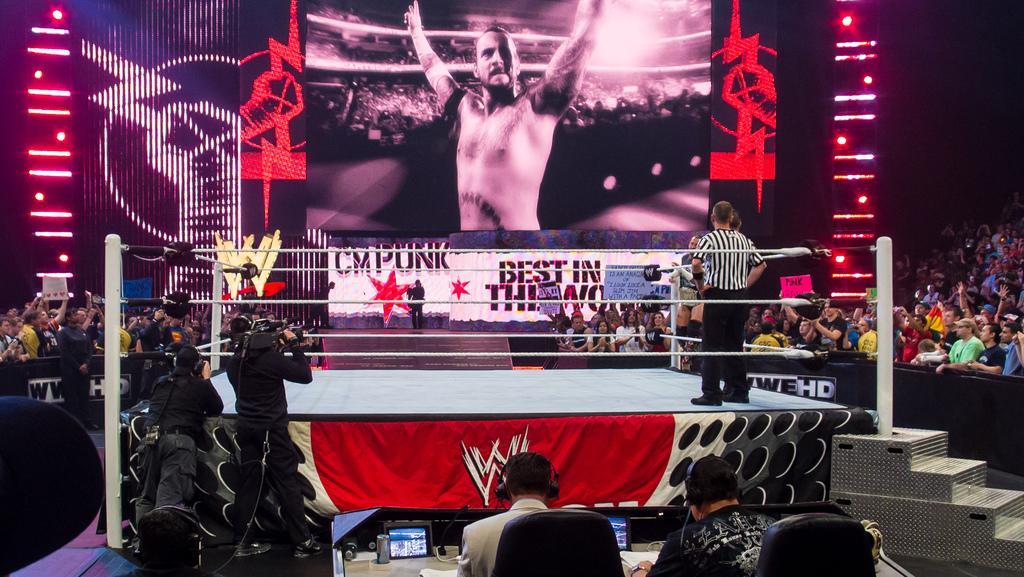How would you summarize this image in a sentence or two? In this image we can see people, boxing ring, steps, screens, chairs, lights, poles, banners, and other objects. 